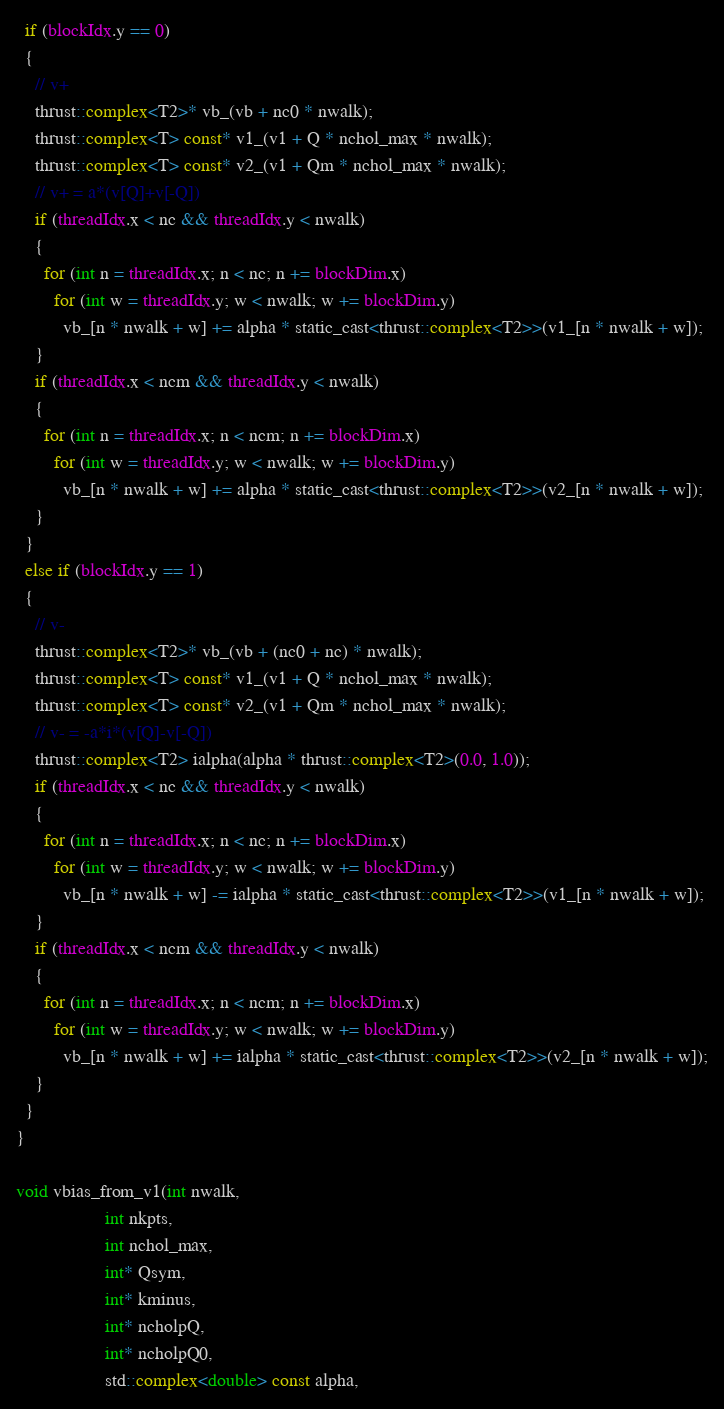<code> <loc_0><loc_0><loc_500><loc_500><_Cuda_>
  if (blockIdx.y == 0)
  {
    // v+
    thrust::complex<T2>* vb_(vb + nc0 * nwalk);
    thrust::complex<T> const* v1_(v1 + Q * nchol_max * nwalk);
    thrust::complex<T> const* v2_(v1 + Qm * nchol_max * nwalk);
    // v+ = a*(v[Q]+v[-Q])
    if (threadIdx.x < nc && threadIdx.y < nwalk)
    {
      for (int n = threadIdx.x; n < nc; n += blockDim.x)
        for (int w = threadIdx.y; w < nwalk; w += blockDim.y)
          vb_[n * nwalk + w] += alpha * static_cast<thrust::complex<T2>>(v1_[n * nwalk + w]);
    }
    if (threadIdx.x < ncm && threadIdx.y < nwalk)
    {
      for (int n = threadIdx.x; n < ncm; n += blockDim.x)
        for (int w = threadIdx.y; w < nwalk; w += blockDim.y)
          vb_[n * nwalk + w] += alpha * static_cast<thrust::complex<T2>>(v2_[n * nwalk + w]);
    }
  }
  else if (blockIdx.y == 1)
  {
    // v-
    thrust::complex<T2>* vb_(vb + (nc0 + nc) * nwalk);
    thrust::complex<T> const* v1_(v1 + Q * nchol_max * nwalk);
    thrust::complex<T> const* v2_(v1 + Qm * nchol_max * nwalk);
    // v- = -a*i*(v[Q]-v[-Q])
    thrust::complex<T2> ialpha(alpha * thrust::complex<T2>(0.0, 1.0));
    if (threadIdx.x < nc && threadIdx.y < nwalk)
    {
      for (int n = threadIdx.x; n < nc; n += blockDim.x)
        for (int w = threadIdx.y; w < nwalk; w += blockDim.y)
          vb_[n * nwalk + w] -= ialpha * static_cast<thrust::complex<T2>>(v1_[n * nwalk + w]);
    }
    if (threadIdx.x < ncm && threadIdx.y < nwalk)
    {
      for (int n = threadIdx.x; n < ncm; n += blockDim.x)
        for (int w = threadIdx.y; w < nwalk; w += blockDim.y)
          vb_[n * nwalk + w] += ialpha * static_cast<thrust::complex<T2>>(v2_[n * nwalk + w]);
    }
  }
}

void vbias_from_v1(int nwalk,
                   int nkpts,
                   int nchol_max,
                   int* Qsym,
                   int* kminus,
                   int* ncholpQ,
                   int* ncholpQ0,
                   std::complex<double> const alpha,</code> 